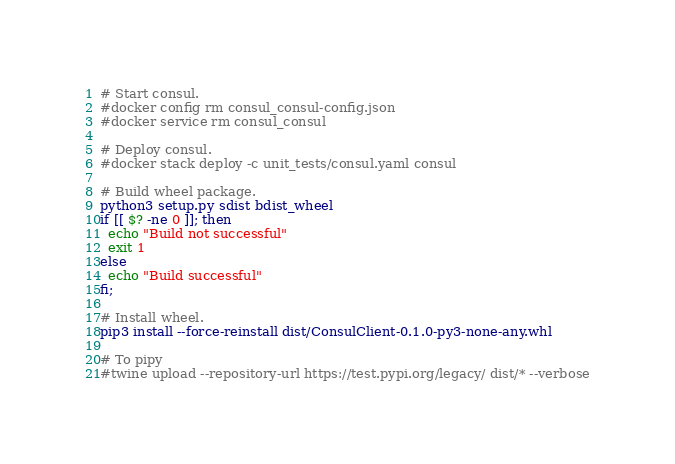<code> <loc_0><loc_0><loc_500><loc_500><_Bash_># Start consul.
#docker config rm consul_consul-config.json
#docker service rm consul_consul

# Deploy consul.
#docker stack deploy -c unit_tests/consul.yaml consul

# Build wheel package.
python3 setup.py sdist bdist_wheel
if [[ $? -ne 0 ]]; then
  echo "Build not successful"
  exit 1
else
  echo "Build successful"
fi;

# Install wheel.
pip3 install --force-reinstall dist/ConsulClient-0.1.0-py3-none-any.whl

# To pipy
#twine upload --repository-url https://test.pypi.org/legacy/ dist/* --verbose

</code> 